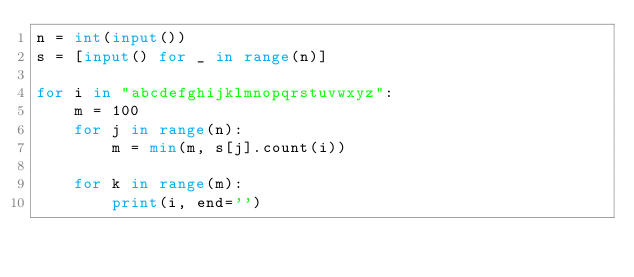Convert code to text. <code><loc_0><loc_0><loc_500><loc_500><_Python_>n = int(input())
s = [input() for _ in range(n)]

for i in "abcdefghijklmnopqrstuvwxyz":
    m = 100
    for j in range(n):
        m = min(m, s[j].count(i))

    for k in range(m):
        print(i, end='')
</code> 